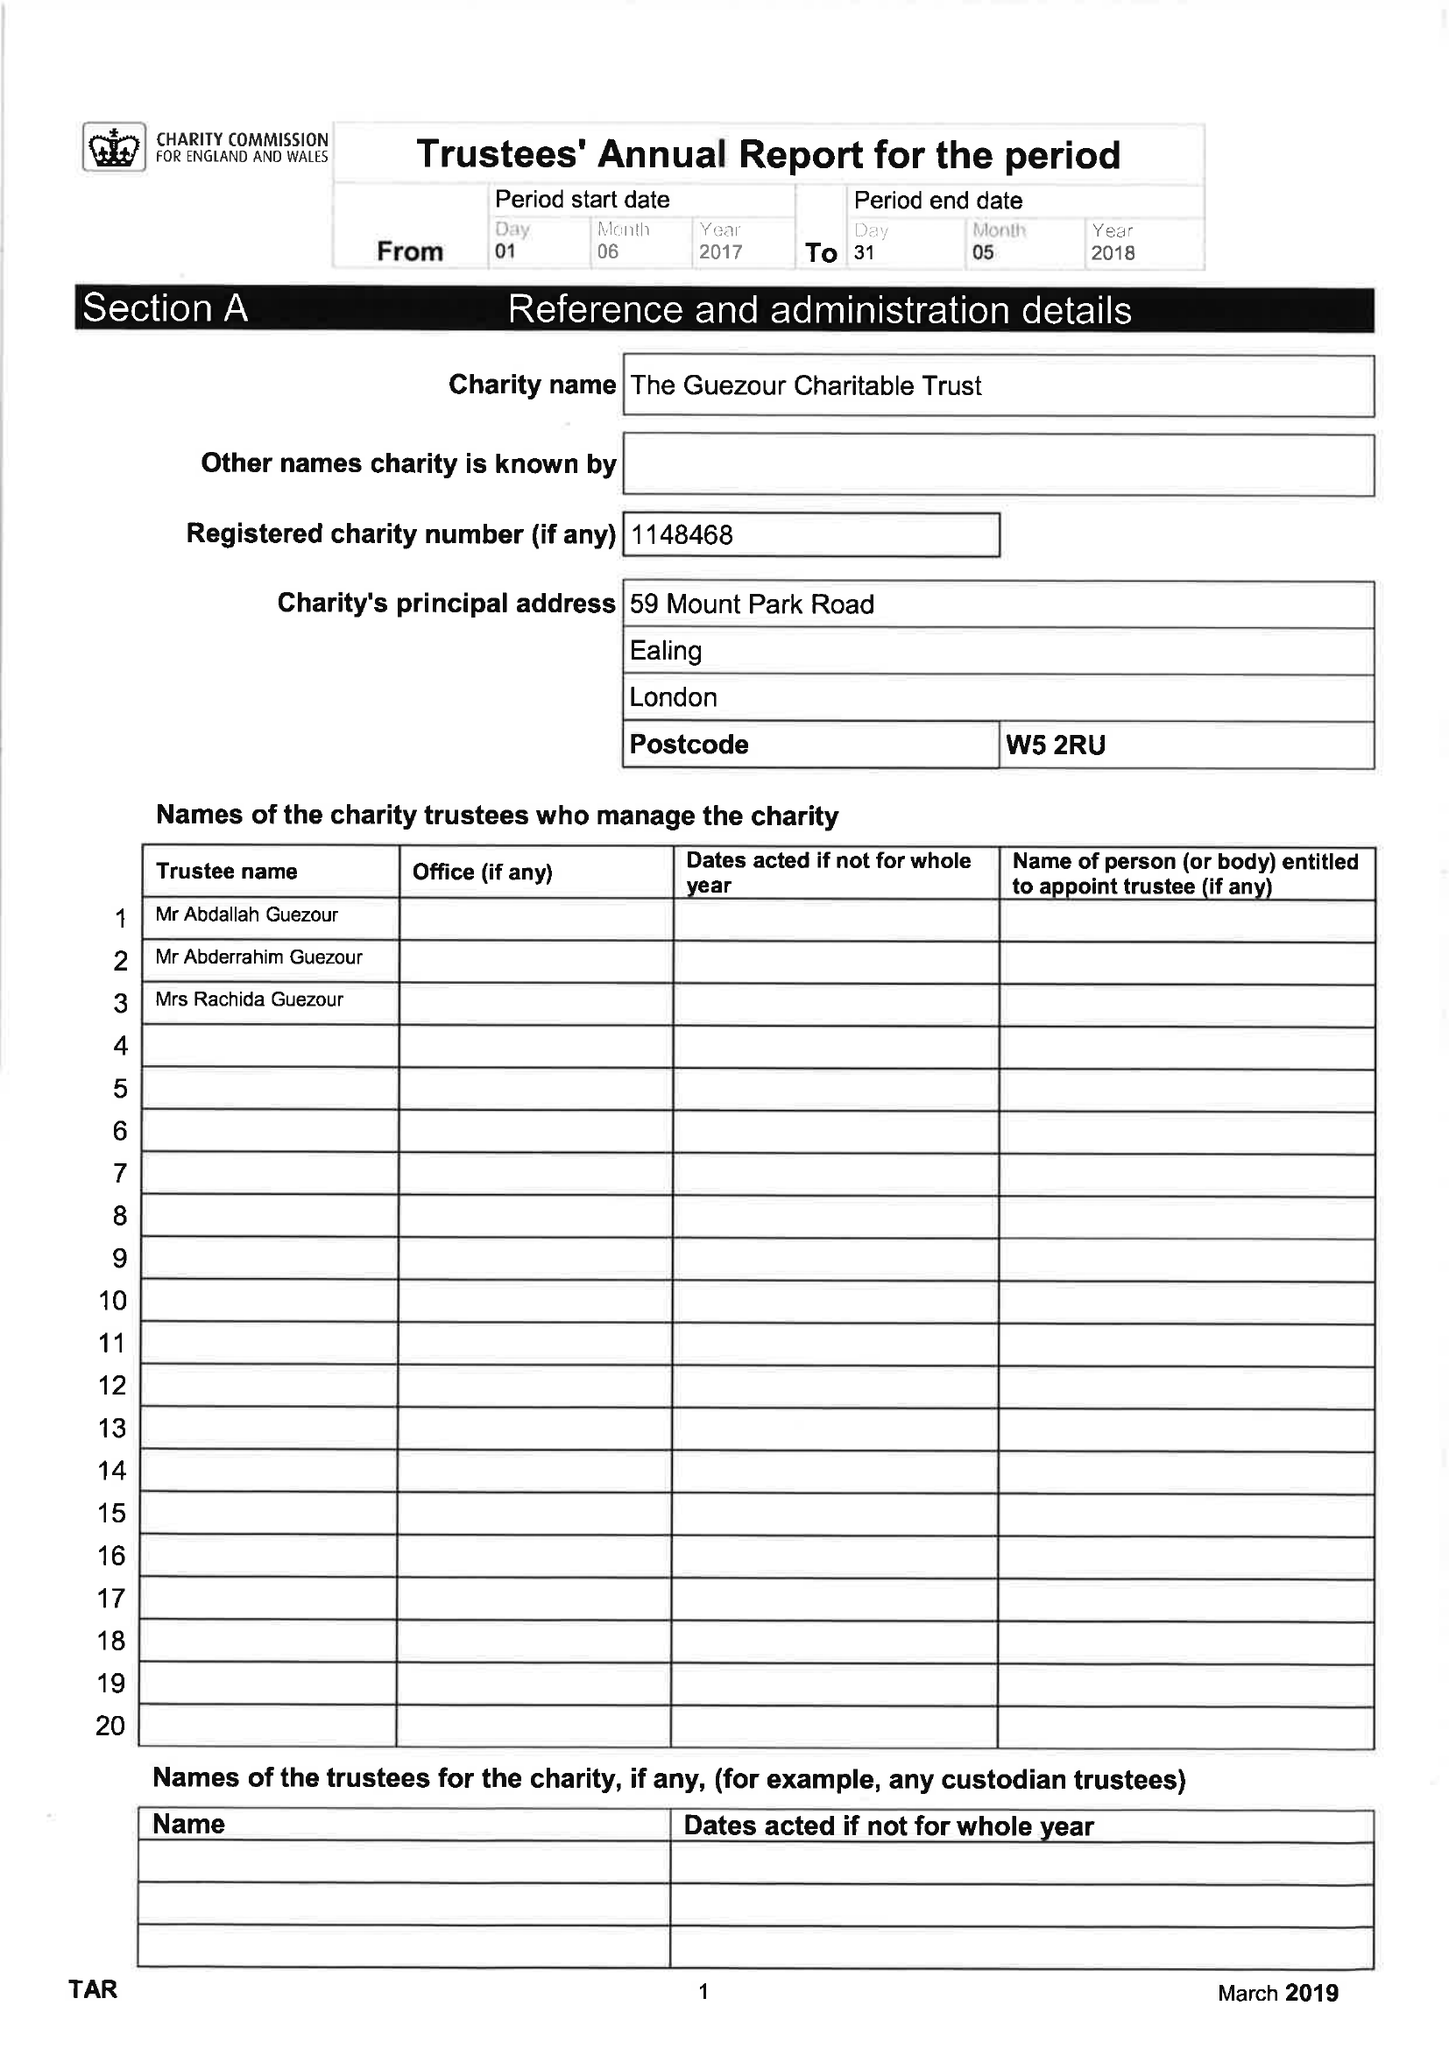What is the value for the income_annually_in_british_pounds?
Answer the question using a single word or phrase. 200523.00 